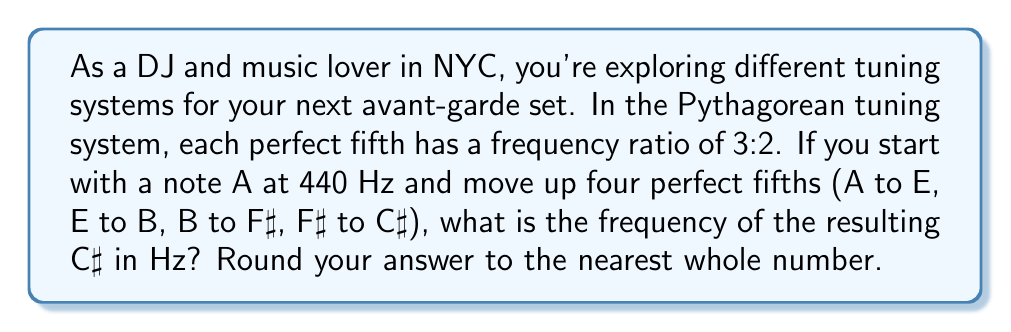Give your solution to this math problem. Let's approach this step-by-step:

1) In the Pythagorean tuning system, each perfect fifth has a ratio of 3:2.

2) We're moving up four perfect fifths, so we need to apply this ratio four times.

3) Let's start with A at 440 Hz and apply the ratio:

   $$ 440 \times (\frac{3}{2})^4 $$

4) Let's calculate this:
   
   $$ 440 \times (\frac{3}{2})^4 = 440 \times \frac{81}{16} $$

5) Now, let's multiply:

   $$ 440 \times \frac{81}{16} = \frac{440 \times 81}{16} = \frac{35640}{16} = 2227.5 \text{ Hz} $$

6) Rounding to the nearest whole number:

   $$ 2227.5 \text{ Hz} \approx 2228 \text{ Hz} $$

Therefore, the C♯ note in Pythagorean tuning, starting from A at 440 Hz and moving up four perfect fifths, would have a frequency of approximately 2228 Hz.
Answer: 2228 Hz 